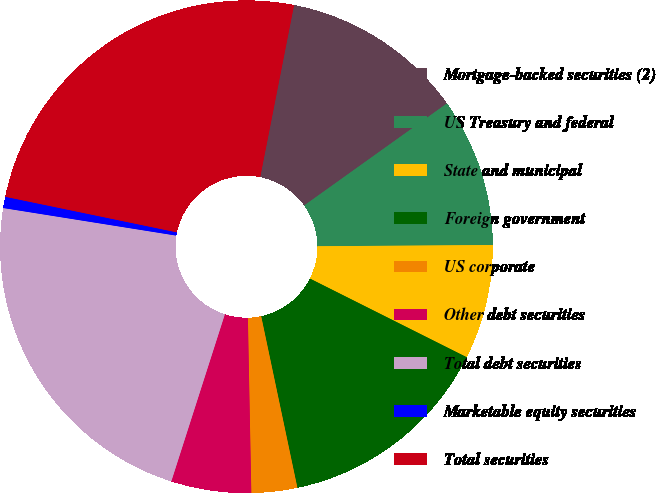Convert chart. <chart><loc_0><loc_0><loc_500><loc_500><pie_chart><fcel>Mortgage-backed securities (2)<fcel>US Treasury and federal<fcel>State and municipal<fcel>Foreign government<fcel>US corporate<fcel>Other debt securities<fcel>Total debt securities<fcel>Marketable equity securities<fcel>Total securities<nl><fcel>12.03%<fcel>9.77%<fcel>7.51%<fcel>14.29%<fcel>3.0%<fcel>5.25%<fcel>22.58%<fcel>0.74%<fcel>24.84%<nl></chart> 